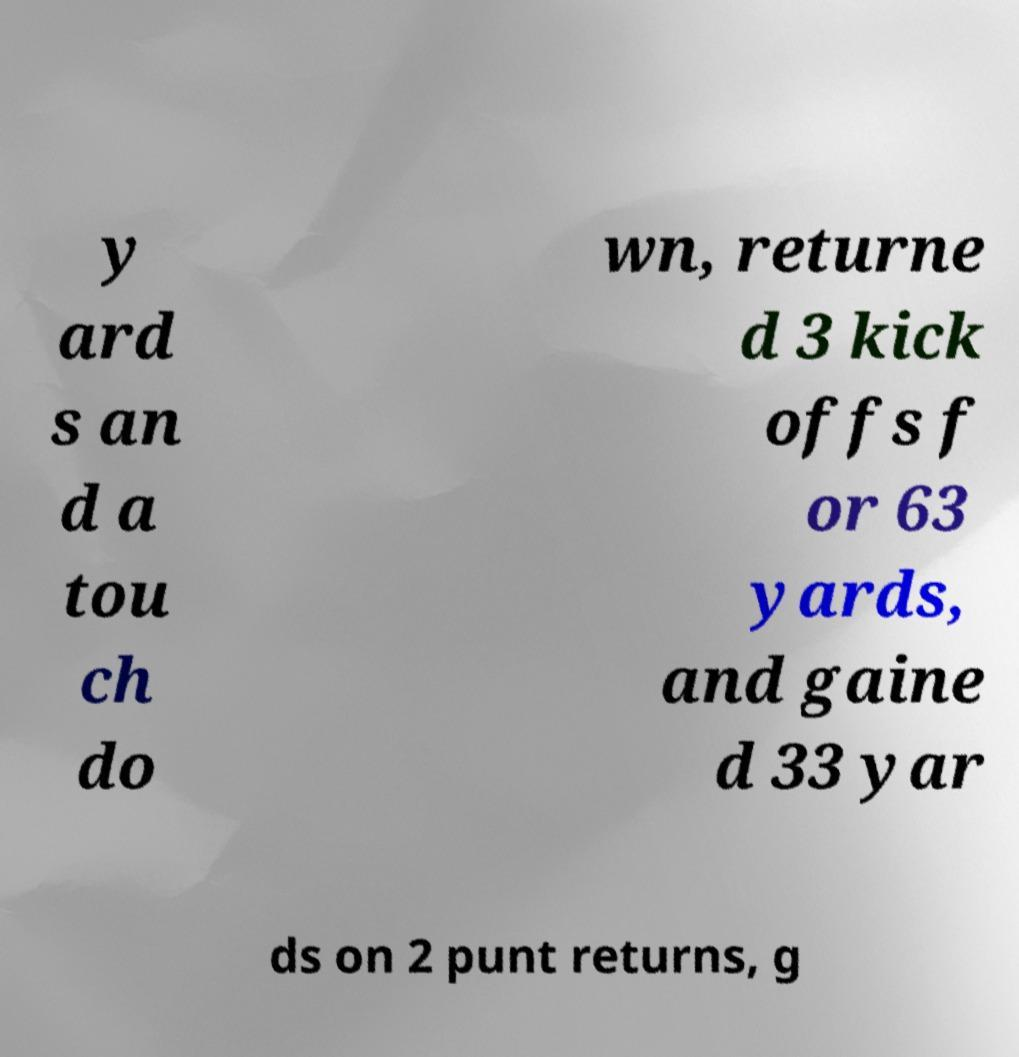Please read and relay the text visible in this image. What does it say? y ard s an d a tou ch do wn, returne d 3 kick offs f or 63 yards, and gaine d 33 yar ds on 2 punt returns, g 